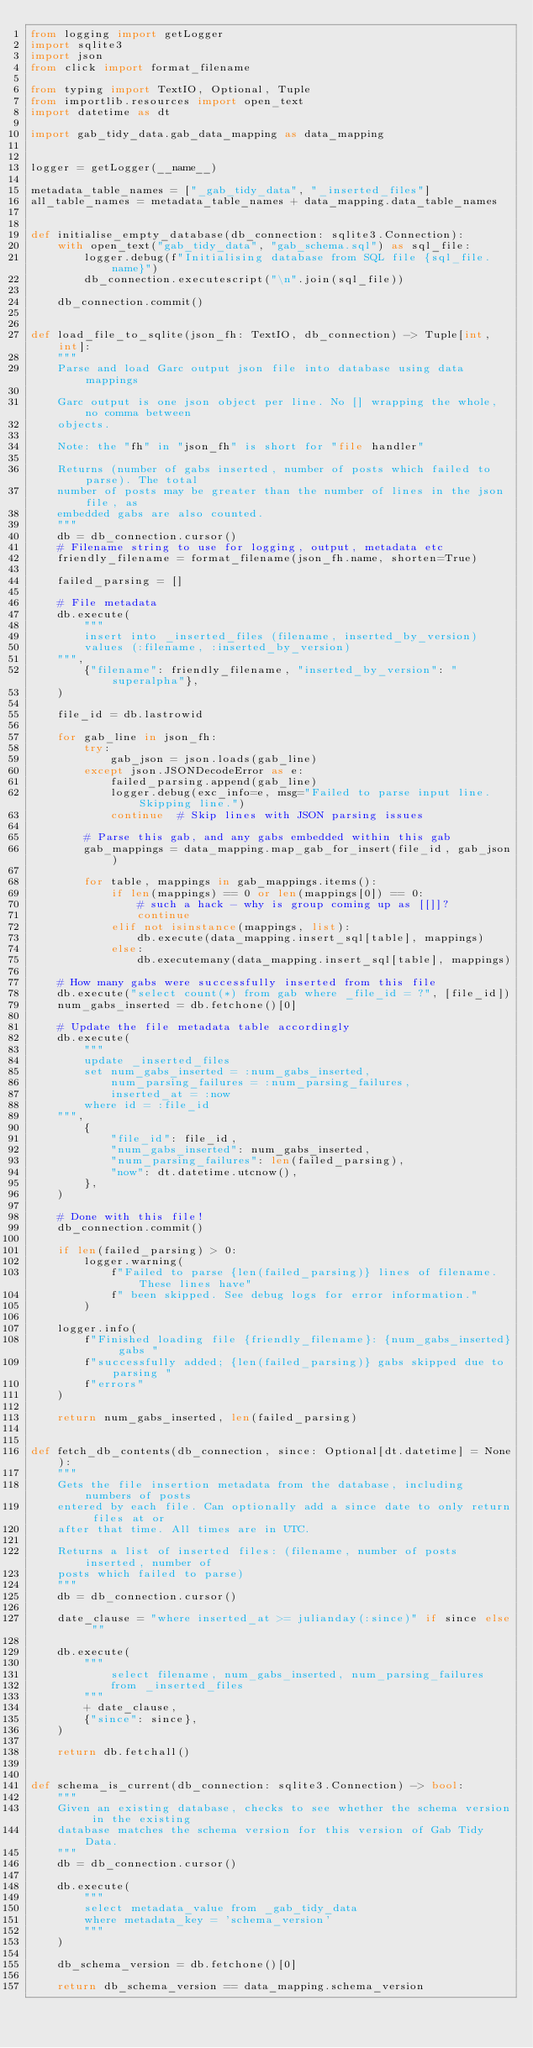Convert code to text. <code><loc_0><loc_0><loc_500><loc_500><_Python_>from logging import getLogger
import sqlite3
import json
from click import format_filename

from typing import TextIO, Optional, Tuple
from importlib.resources import open_text
import datetime as dt

import gab_tidy_data.gab_data_mapping as data_mapping


logger = getLogger(__name__)

metadata_table_names = ["_gab_tidy_data", "_inserted_files"]
all_table_names = metadata_table_names + data_mapping.data_table_names


def initialise_empty_database(db_connection: sqlite3.Connection):
    with open_text("gab_tidy_data", "gab_schema.sql") as sql_file:
        logger.debug(f"Initialising database from SQL file {sql_file.name}")
        db_connection.executescript("\n".join(sql_file))

    db_connection.commit()


def load_file_to_sqlite(json_fh: TextIO, db_connection) -> Tuple[int, int]:
    """
    Parse and load Garc output json file into database using data mappings

    Garc output is one json object per line. No [] wrapping the whole, no comma between
    objects.

    Note: the "fh" in "json_fh" is short for "file handler"

    Returns (number of gabs inserted, number of posts which failed to parse). The total
    number of posts may be greater than the number of lines in the json file, as
    embedded gabs are also counted.
    """
    db = db_connection.cursor()
    # Filename string to use for logging, output, metadata etc
    friendly_filename = format_filename(json_fh.name, shorten=True)

    failed_parsing = []

    # File metadata
    db.execute(
        """
        insert into _inserted_files (filename, inserted_by_version)
        values (:filename, :inserted_by_version)
    """,
        {"filename": friendly_filename, "inserted_by_version": "superalpha"},
    )

    file_id = db.lastrowid

    for gab_line in json_fh:
        try:
            gab_json = json.loads(gab_line)
        except json.JSONDecodeError as e:
            failed_parsing.append(gab_line)
            logger.debug(exc_info=e, msg="Failed to parse input line. Skipping line.")
            continue  # Skip lines with JSON parsing issues

        # Parse this gab, and any gabs embedded within this gab
        gab_mappings = data_mapping.map_gab_for_insert(file_id, gab_json)

        for table, mappings in gab_mappings.items():
            if len(mappings) == 0 or len(mappings[0]) == 0:
                # such a hack - why is group coming up as [[]]?
                continue
            elif not isinstance(mappings, list):
                db.execute(data_mapping.insert_sql[table], mappings)
            else:
                db.executemany(data_mapping.insert_sql[table], mappings)

    # How many gabs were successfully inserted from this file
    db.execute("select count(*) from gab where _file_id = ?", [file_id])
    num_gabs_inserted = db.fetchone()[0]

    # Update the file metadata table accordingly
    db.execute(
        """
        update _inserted_files
        set num_gabs_inserted = :num_gabs_inserted,
            num_parsing_failures = :num_parsing_failures,
            inserted_at = :now
        where id = :file_id
    """,
        {
            "file_id": file_id,
            "num_gabs_inserted": num_gabs_inserted,
            "num_parsing_failures": len(failed_parsing),
            "now": dt.datetime.utcnow(),
        },
    )

    # Done with this file!
    db_connection.commit()

    if len(failed_parsing) > 0:
        logger.warning(
            f"Failed to parse {len(failed_parsing)} lines of filename. These lines have"
            f" been skipped. See debug logs for error information."
        )

    logger.info(
        f"Finished loading file {friendly_filename}: {num_gabs_inserted} gabs "
        f"successfully added; {len(failed_parsing)} gabs skipped due to parsing "
        f"errors"
    )

    return num_gabs_inserted, len(failed_parsing)


def fetch_db_contents(db_connection, since: Optional[dt.datetime] = None):
    """
    Gets the file insertion metadata from the database, including numbers of posts
    entered by each file. Can optionally add a since date to only return files at or
    after that time. All times are in UTC.

    Returns a list of inserted files: (filename, number of posts inserted, number of
    posts which failed to parse)
    """
    db = db_connection.cursor()

    date_clause = "where inserted_at >= julianday(:since)" if since else ""

    db.execute(
        """
            select filename, num_gabs_inserted, num_parsing_failures
            from _inserted_files
        """
        + date_clause,
        {"since": since},
    )

    return db.fetchall()


def schema_is_current(db_connection: sqlite3.Connection) -> bool:
    """
    Given an existing database, checks to see whether the schema version in the existing
    database matches the schema version for this version of Gab Tidy Data.
    """
    db = db_connection.cursor()

    db.execute(
        """
        select metadata_value from _gab_tidy_data
        where metadata_key = 'schema_version'
        """
    )

    db_schema_version = db.fetchone()[0]

    return db_schema_version == data_mapping.schema_version
</code> 